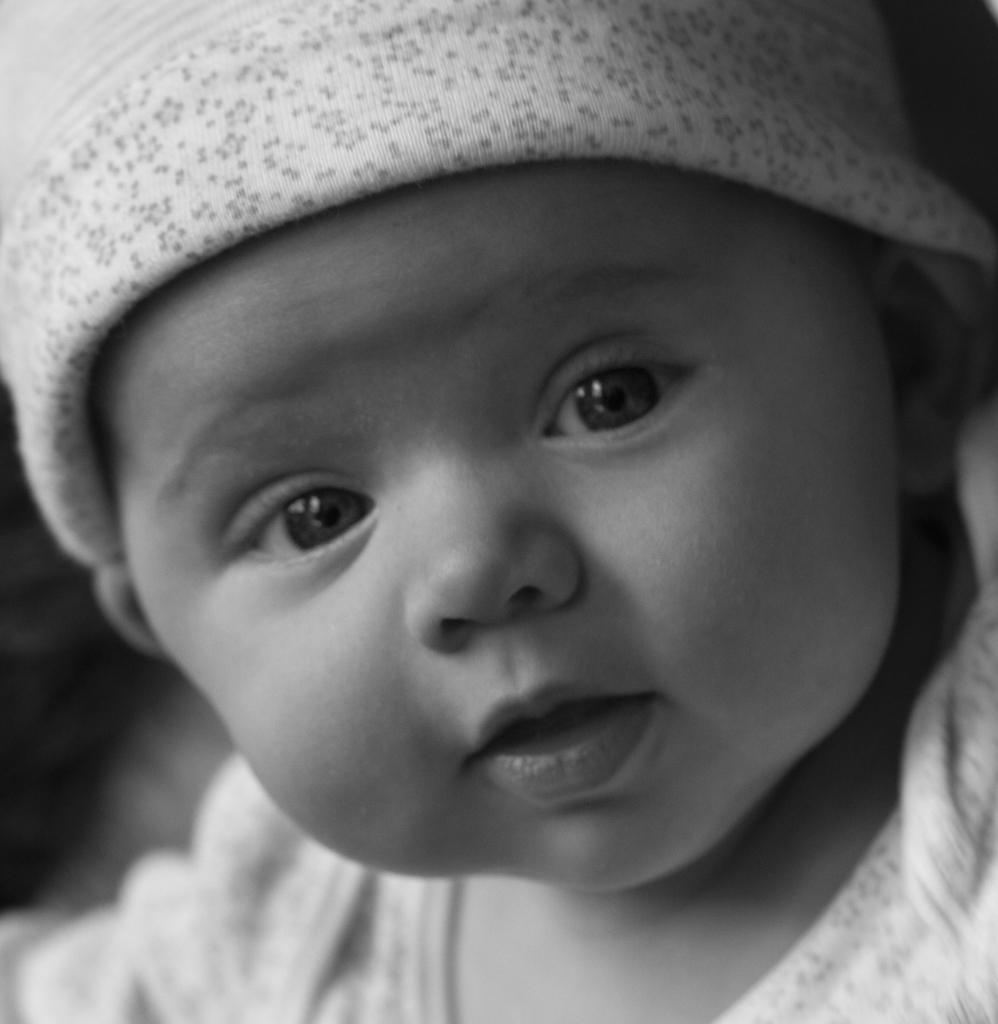What is the color scheme of the image? The image is black and white. What subject is featured in the image? There is a baby in the image. What direction is the rod pointing in the image? There is no rod present in the image. 